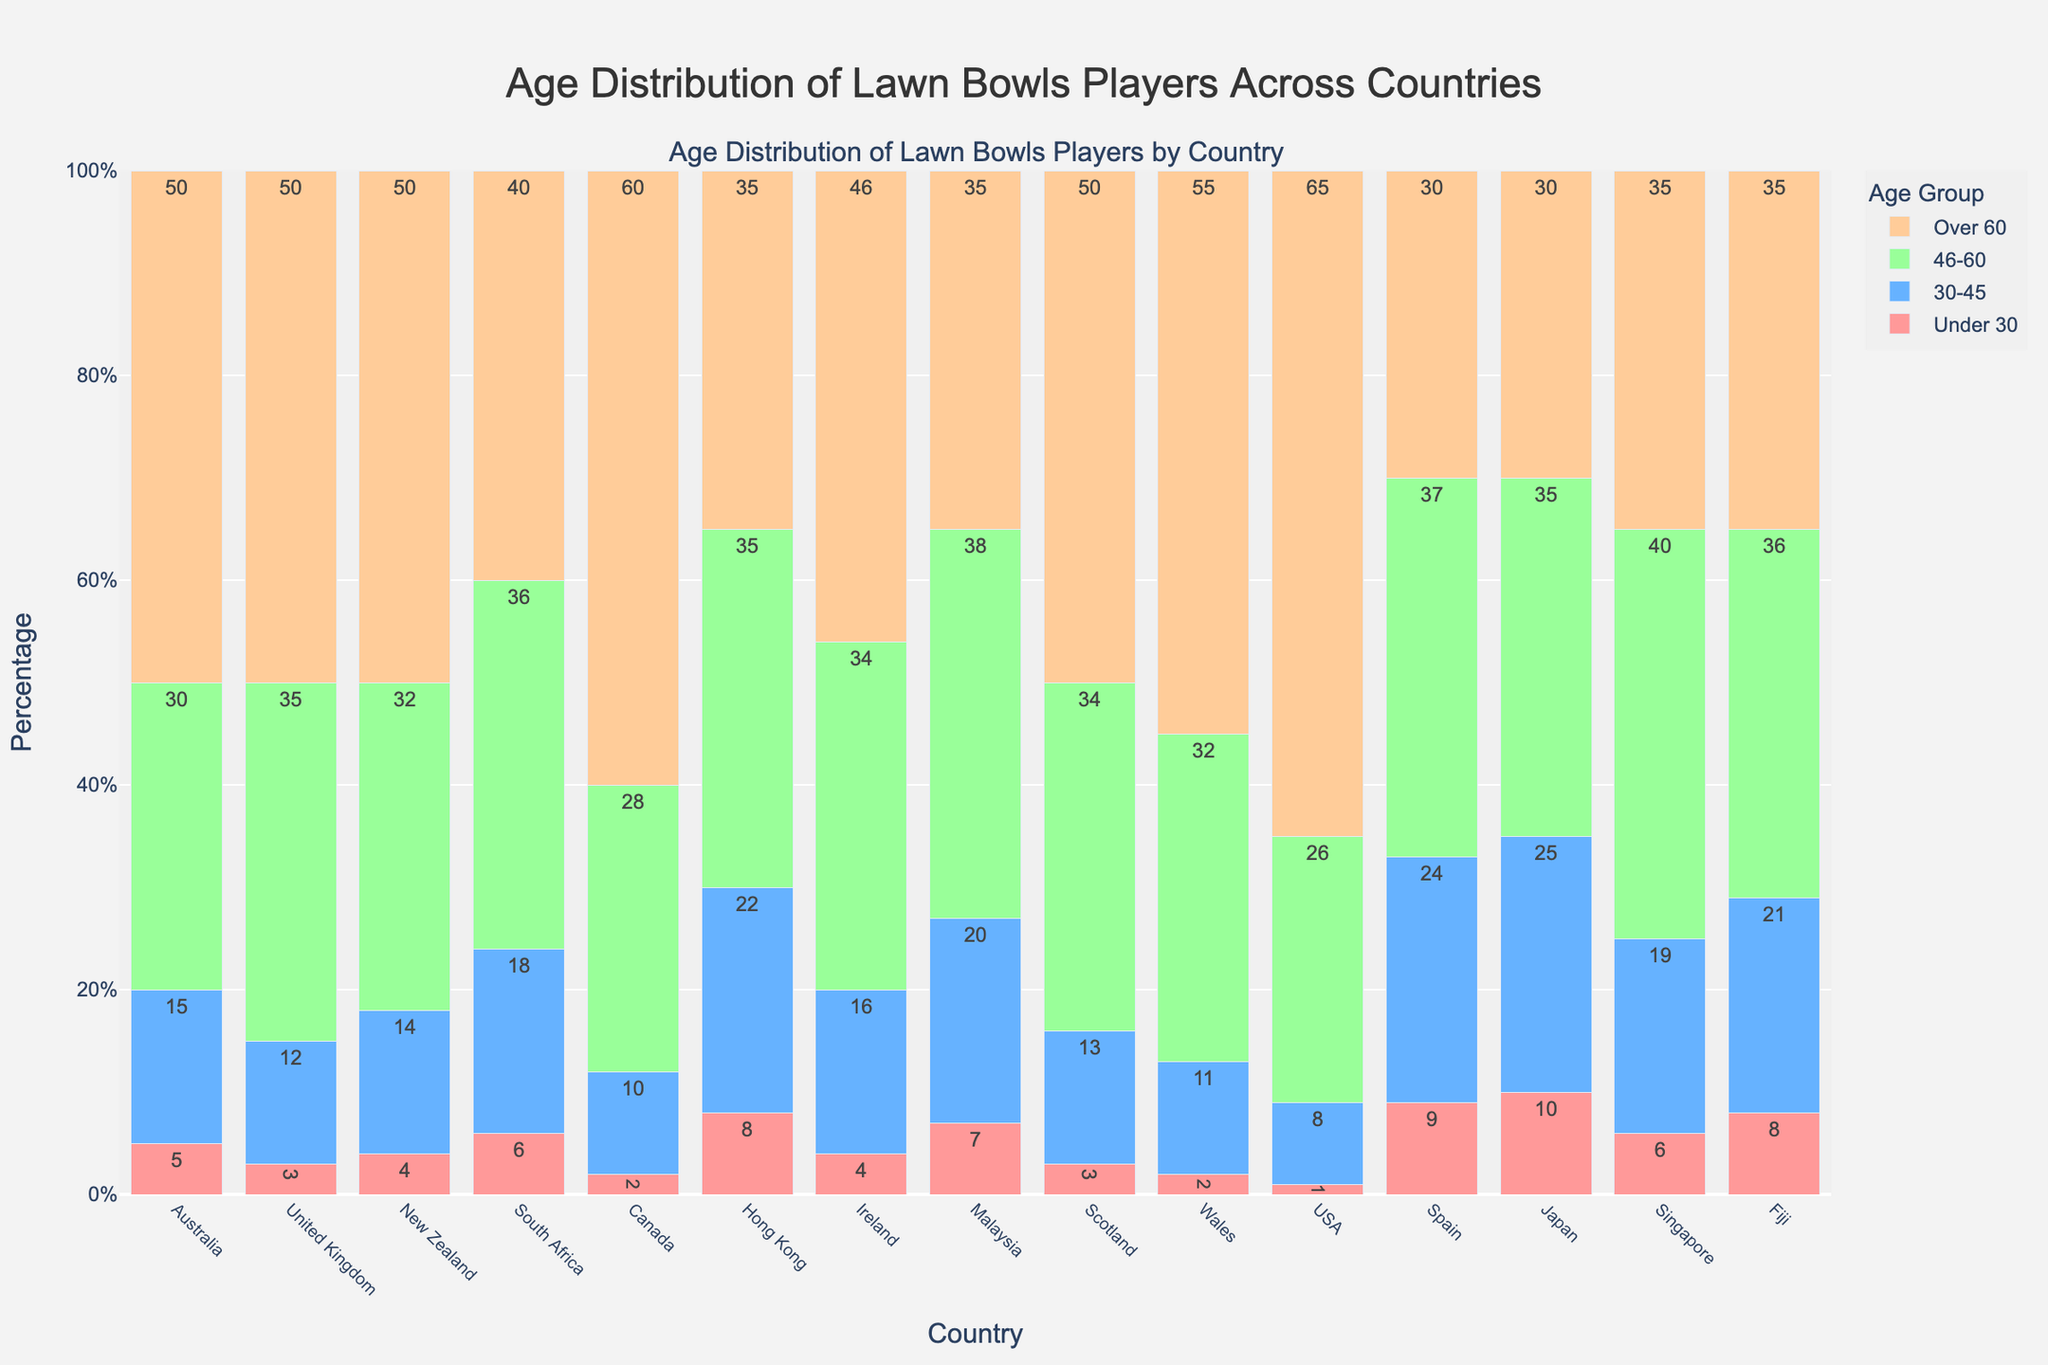what age group has the highest percentage in Australia? The highest bar for Australia in the stacked bar chart belongs to the "Over 60" age group.
Answer: Over 60 how does the percentage of players under 30 in New Zealand compare to that in Spain? New Zealand has a lower percentage of players under 30 (4%) compared to Spain (9%).
Answer: New Zealand has a lower percentage which country has the most balanced age distribution across all age groups? Hong Kong shows the most balanced distribution, with percentages in each age group (8%, 22%, 35%, 35%) relatively close to each other compared to other countries.
Answer: Hong Kong which country has the highest percentage of players over 60? The USA has the highest percentage of players over 60, indicated by the tallest "Over 60" section in the bar.
Answer: USA subtract the percentage of players aged 30-45 in Malaysia from those aged 46-60 in the same country The percentage of players aged 46-60 in Malaysia is 38%, and those aged 30-45 is 20%. So, the difference is 38 - 20 = 18%.
Answer: 18% which two countries have the same highest percentage of players aged 46-60? Both the United Kingdom and Scotland have the highest percentage of players aged 46-60 at 35%.
Answer: United Kingdom and Scotland what is the total percentage of lawn bowls players under 30 in Fiji and Japan? Fiji has 8% and Japan has 10% of players under 30. Sum is 8% + 10% = 18%.
Answer: 18% which country has the smallest percentage for the 30-45 age group? The USA has the smallest percentage for the 30-45 age group at 8%.
Answer: USA adding the percentages of players under 30 and over 60 for Singapore, what is the result? Singapore has 6% under 30 and 35% over 60. The total is 6 + 35 = 41%.
Answer: 41% is there any country with a percentage for the 46-60 age group equal to that of the 30-45 age group in Malaysia? Yes, Hong Kong has 35% for the 46-60 age group, which is equal to the 30-45 percentage in Malaysia.
Answer: Hong Kong 